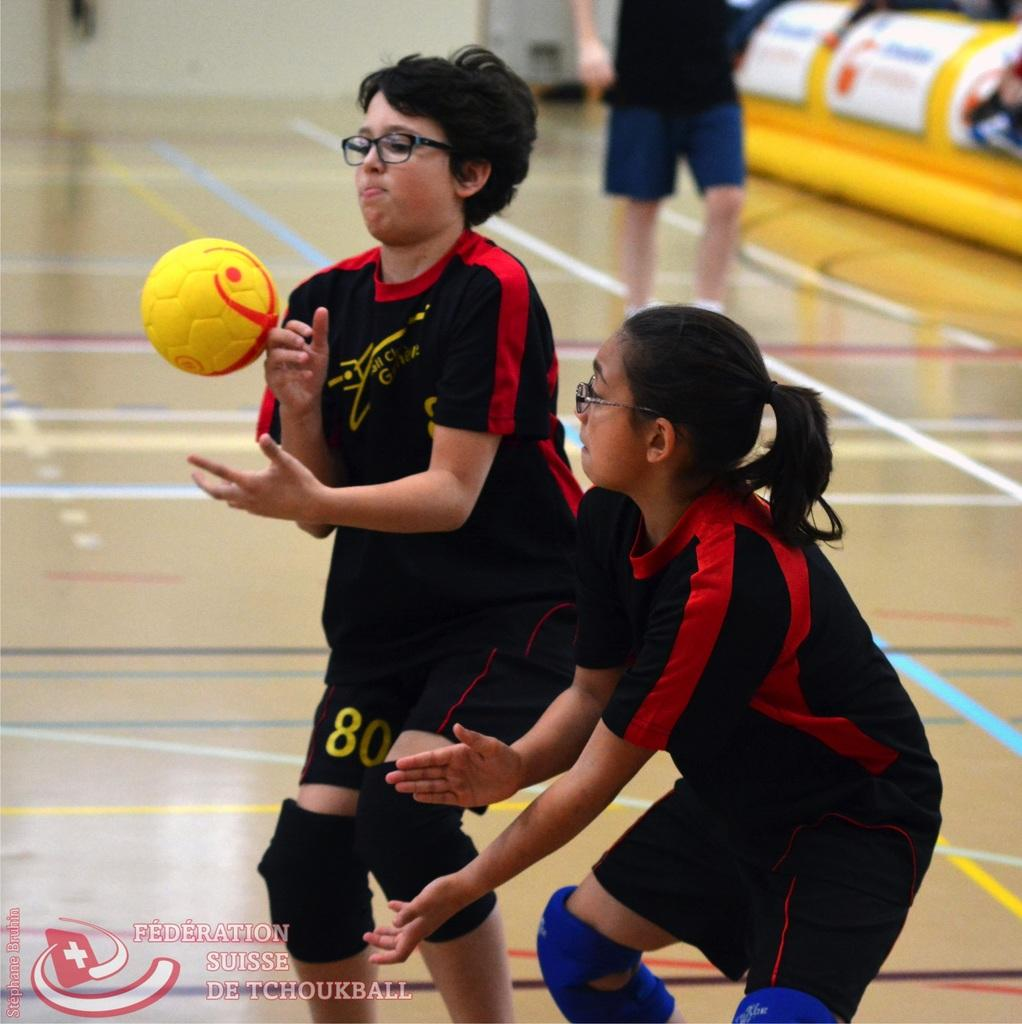Who or what can be seen in the image? There are people in the image. What is happening with the ball in the image? The ball is in the air. What part of the environment is visible in the image? The floor is visible in the image. How would you describe the background of the image? The background of the image is blurry. What type of objects can be seen in the background? There are boards and a wall in the background. What type of distribution is being made in the image? There is no distribution activity present in the image. Can you see a notebook in the image? There is no notebook visible in the image. 